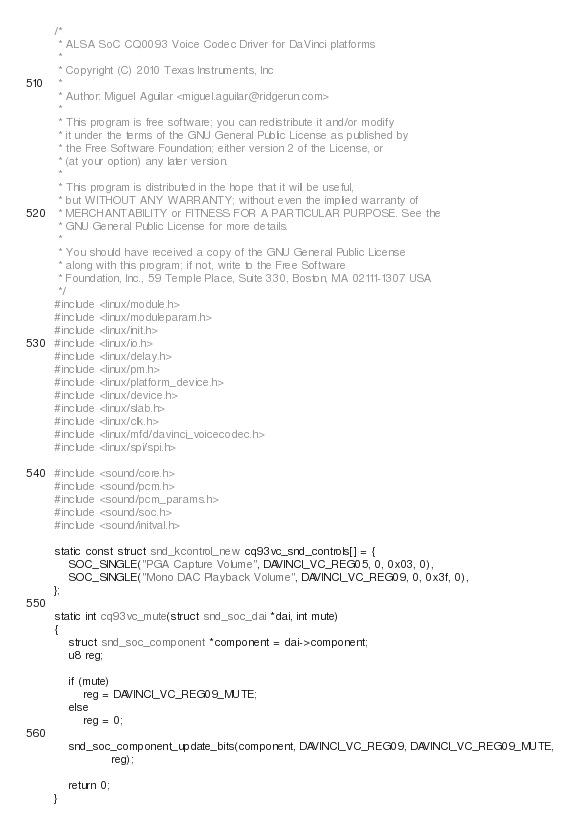Convert code to text. <code><loc_0><loc_0><loc_500><loc_500><_C_>/*
 * ALSA SoC CQ0093 Voice Codec Driver for DaVinci platforms
 *
 * Copyright (C) 2010 Texas Instruments, Inc
 *
 * Author: Miguel Aguilar <miguel.aguilar@ridgerun.com>
 *
 * This program is free software; you can redistribute it and/or modify
 * it under the terms of the GNU General Public License as published by
 * the Free Software Foundation; either version 2 of the License, or
 * (at your option) any later version.
 *
 * This program is distributed in the hope that it will be useful,
 * but WITHOUT ANY WARRANTY; without even the implied warranty of
 * MERCHANTABILITY or FITNESS FOR A PARTICULAR PURPOSE. See the
 * GNU General Public License for more details.
 *
 * You should have received a copy of the GNU General Public License
 * along with this program; if not, write to the Free Software
 * Foundation, Inc., 59 Temple Place, Suite 330, Boston, MA 02111-1307 USA
 */
#include <linux/module.h>
#include <linux/moduleparam.h>
#include <linux/init.h>
#include <linux/io.h>
#include <linux/delay.h>
#include <linux/pm.h>
#include <linux/platform_device.h>
#include <linux/device.h>
#include <linux/slab.h>
#include <linux/clk.h>
#include <linux/mfd/davinci_voicecodec.h>
#include <linux/spi/spi.h>

#include <sound/core.h>
#include <sound/pcm.h>
#include <sound/pcm_params.h>
#include <sound/soc.h>
#include <sound/initval.h>

static const struct snd_kcontrol_new cq93vc_snd_controls[] = {
	SOC_SINGLE("PGA Capture Volume", DAVINCI_VC_REG05, 0, 0x03, 0),
	SOC_SINGLE("Mono DAC Playback Volume", DAVINCI_VC_REG09, 0, 0x3f, 0),
};

static int cq93vc_mute(struct snd_soc_dai *dai, int mute)
{
	struct snd_soc_component *component = dai->component;
	u8 reg;

	if (mute)
		reg = DAVINCI_VC_REG09_MUTE;
	else
		reg = 0;

	snd_soc_component_update_bits(component, DAVINCI_VC_REG09, DAVINCI_VC_REG09_MUTE,
			    reg);

	return 0;
}
</code> 